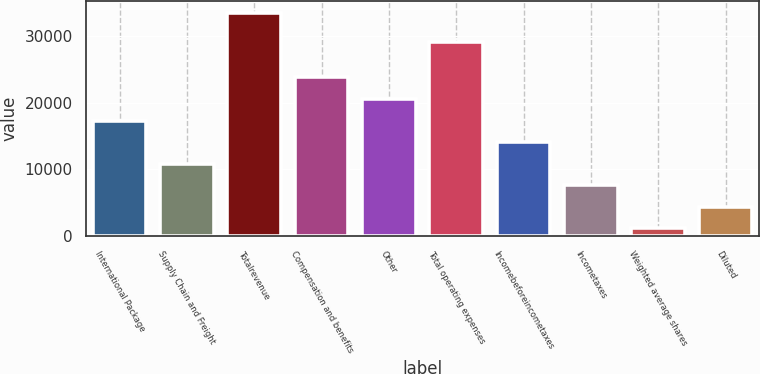Convert chart to OTSL. <chart><loc_0><loc_0><loc_500><loc_500><bar_chart><fcel>International Package<fcel>Supply Chain and Freight<fcel>Totalrevenue<fcel>Compensation and benefits<fcel>Other<fcel>Total operating expenses<fcel>Incomebeforeincometaxes<fcel>Incometaxes<fcel>Weighted average shares<fcel>Diluted<nl><fcel>17306.5<fcel>10835.1<fcel>33485<fcel>23777.9<fcel>20542.2<fcel>29040<fcel>14070.8<fcel>7599.4<fcel>1128<fcel>4363.7<nl></chart> 